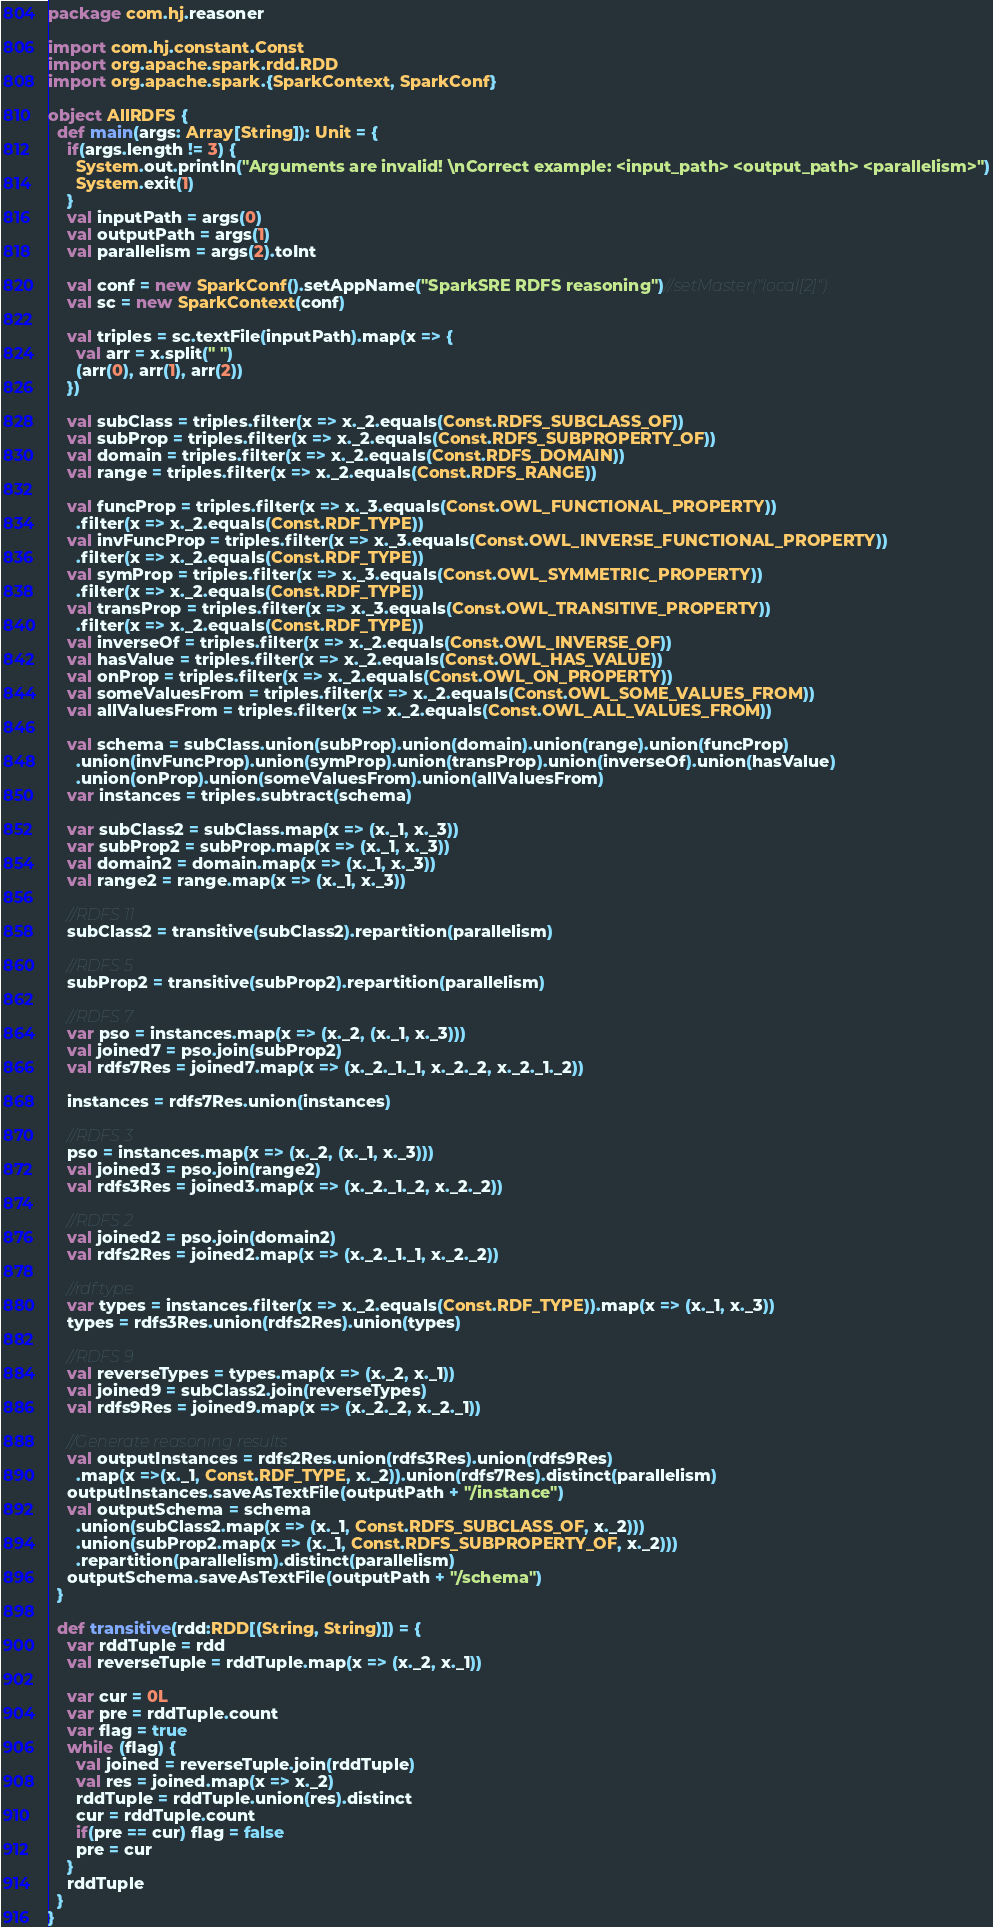<code> <loc_0><loc_0><loc_500><loc_500><_Scala_>package com.hj.reasoner

import com.hj.constant.Const
import org.apache.spark.rdd.RDD
import org.apache.spark.{SparkContext, SparkConf}

object AllRDFS {
  def main(args: Array[String]): Unit = {
    if(args.length != 3) {
      System.out.println("Arguments are invalid! \nCorrect example: <input_path> <output_path> <parallelism>")
      System.exit(1)
    }
    val inputPath = args(0)
    val outputPath = args(1)
    val parallelism = args(2).toInt

    val conf = new SparkConf().setAppName("SparkSRE RDFS reasoning")//.setMaster("local[2]")
    val sc = new SparkContext(conf)

    val triples = sc.textFile(inputPath).map(x => {
      val arr = x.split(" ")
      (arr(0), arr(1), arr(2))
    })

    val subClass = triples.filter(x => x._2.equals(Const.RDFS_SUBCLASS_OF))
    val subProp = triples.filter(x => x._2.equals(Const.RDFS_SUBPROPERTY_OF))
    val domain = triples.filter(x => x._2.equals(Const.RDFS_DOMAIN))
    val range = triples.filter(x => x._2.equals(Const.RDFS_RANGE))

    val funcProp = triples.filter(x => x._3.equals(Const.OWL_FUNCTIONAL_PROPERTY))
      .filter(x => x._2.equals(Const.RDF_TYPE))
    val invFuncProp = triples.filter(x => x._3.equals(Const.OWL_INVERSE_FUNCTIONAL_PROPERTY))
      .filter(x => x._2.equals(Const.RDF_TYPE))
    val symProp = triples.filter(x => x._3.equals(Const.OWL_SYMMETRIC_PROPERTY))
      .filter(x => x._2.equals(Const.RDF_TYPE))
    val transProp = triples.filter(x => x._3.equals(Const.OWL_TRANSITIVE_PROPERTY))
      .filter(x => x._2.equals(Const.RDF_TYPE))
    val inverseOf = triples.filter(x => x._2.equals(Const.OWL_INVERSE_OF))
    val hasValue = triples.filter(x => x._2.equals(Const.OWL_HAS_VALUE))
    val onProp = triples.filter(x => x._2.equals(Const.OWL_ON_PROPERTY))
    val someValuesFrom = triples.filter(x => x._2.equals(Const.OWL_SOME_VALUES_FROM))
    val allValuesFrom = triples.filter(x => x._2.equals(Const.OWL_ALL_VALUES_FROM))

    val schema = subClass.union(subProp).union(domain).union(range).union(funcProp)
      .union(invFuncProp).union(symProp).union(transProp).union(inverseOf).union(hasValue)
      .union(onProp).union(someValuesFrom).union(allValuesFrom)
    var instances = triples.subtract(schema)

    var subClass2 = subClass.map(x => (x._1, x._3))
    var subProp2 = subProp.map(x => (x._1, x._3))
    val domain2 = domain.map(x => (x._1, x._3))
    val range2 = range.map(x => (x._1, x._3))

    //RDFS 11
    subClass2 = transitive(subClass2).repartition(parallelism)

    //RDFS 5
    subProp2 = transitive(subProp2).repartition(parallelism)

    //RDFS 7
    var pso = instances.map(x => (x._2, (x._1, x._3)))
    val joined7 = pso.join(subProp2)
    val rdfs7Res = joined7.map(x => (x._2._1._1, x._2._2, x._2._1._2))

    instances = rdfs7Res.union(instances)

    //RDFS 3
    pso = instances.map(x => (x._2, (x._1, x._3)))
    val joined3 = pso.join(range2)
    val rdfs3Res = joined3.map(x => (x._2._1._2, x._2._2))

    //RDFS 2
    val joined2 = pso.join(domain2)
    val rdfs2Res = joined2.map(x => (x._2._1._1, x._2._2))

    //rdf:type
    var types = instances.filter(x => x._2.equals(Const.RDF_TYPE)).map(x => (x._1, x._3))
    types = rdfs3Res.union(rdfs2Res).union(types)

    //RDFS 9
    val reverseTypes = types.map(x => (x._2, x._1))
    val joined9 = subClass2.join(reverseTypes)
    val rdfs9Res = joined9.map(x => (x._2._2, x._2._1))

    //Generate reasoning results
    val outputInstances = rdfs2Res.union(rdfs3Res).union(rdfs9Res)
      .map(x =>(x._1, Const.RDF_TYPE, x._2)).union(rdfs7Res).distinct(parallelism)
    outputInstances.saveAsTextFile(outputPath + "/instance")
    val outputSchema = schema
      .union(subClass2.map(x => (x._1, Const.RDFS_SUBCLASS_OF, x._2)))
      .union(subProp2.map(x => (x._1, Const.RDFS_SUBPROPERTY_OF, x._2)))
      .repartition(parallelism).distinct(parallelism)
    outputSchema.saveAsTextFile(outputPath + "/schema")
  }

  def transitive(rdd:RDD[(String, String)]) = {
    var rddTuple = rdd
    val reverseTuple = rddTuple.map(x => (x._2, x._1))

    var cur = 0L
    var pre = rddTuple.count
    var flag = true
    while (flag) {
      val joined = reverseTuple.join(rddTuple)
      val res = joined.map(x => x._2)
      rddTuple = rddTuple.union(res).distinct
      cur = rddTuple.count
      if(pre == cur) flag = false
      pre = cur
    }
    rddTuple
  }
}
</code> 